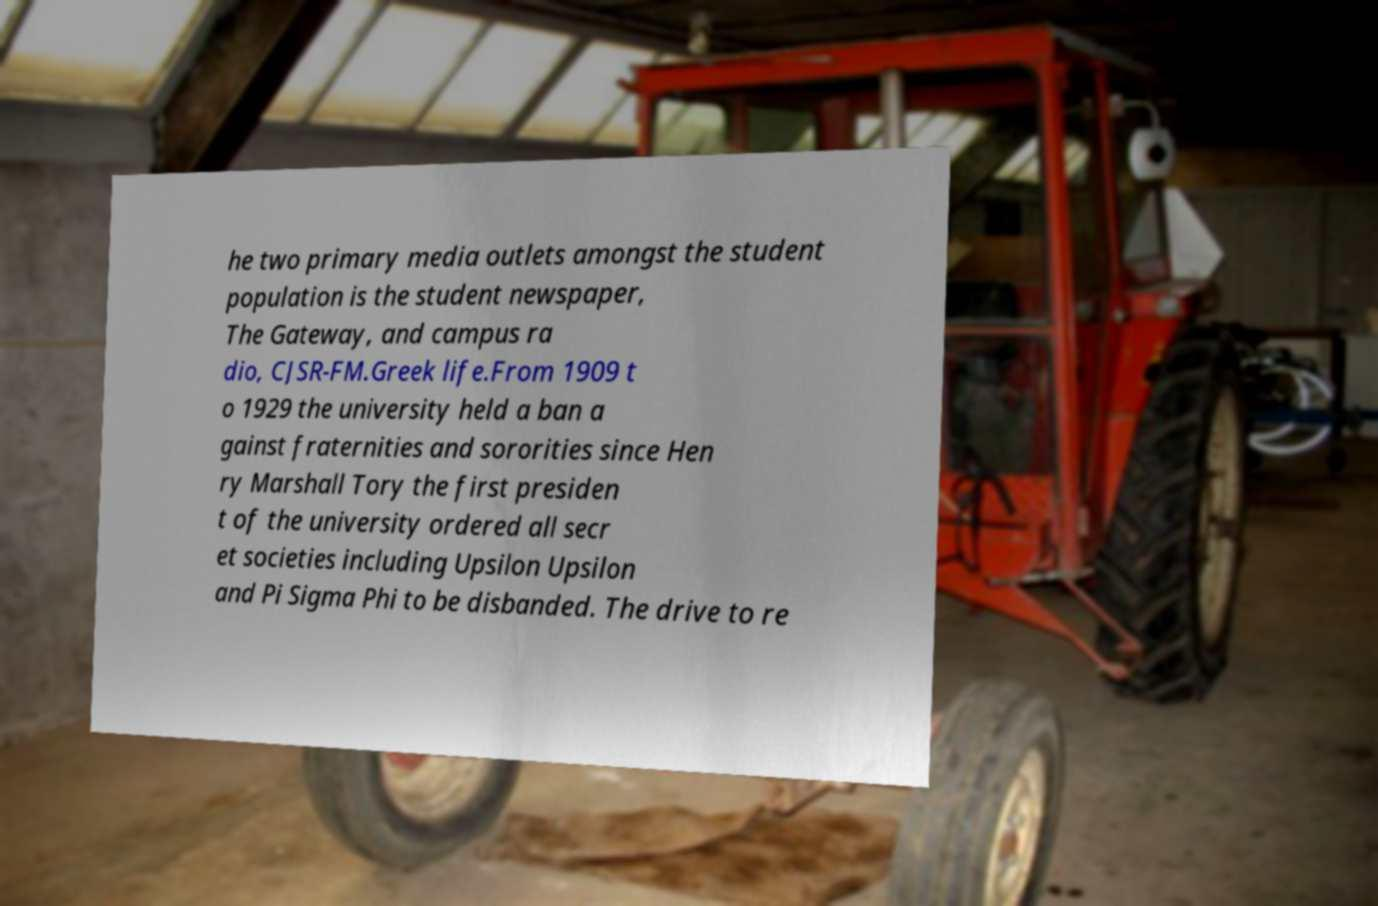For documentation purposes, I need the text within this image transcribed. Could you provide that? he two primary media outlets amongst the student population is the student newspaper, The Gateway, and campus ra dio, CJSR-FM.Greek life.From 1909 t o 1929 the university held a ban a gainst fraternities and sororities since Hen ry Marshall Tory the first presiden t of the university ordered all secr et societies including Upsilon Upsilon and Pi Sigma Phi to be disbanded. The drive to re 